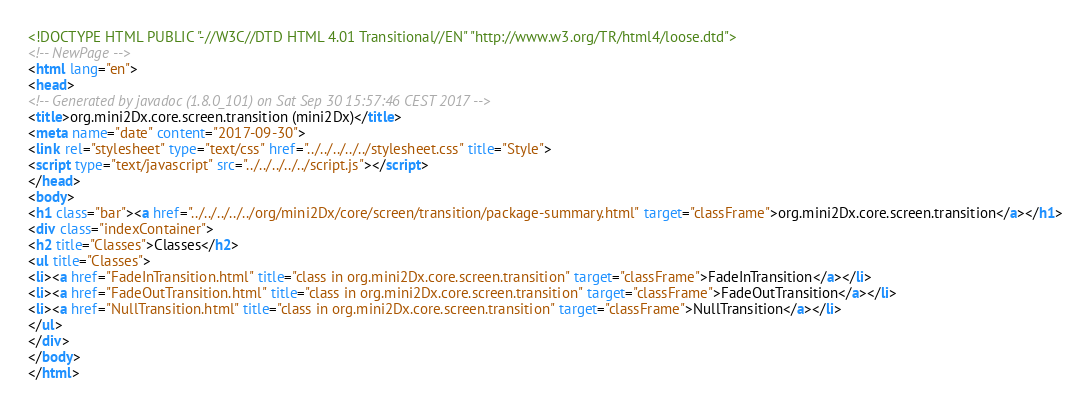Convert code to text. <code><loc_0><loc_0><loc_500><loc_500><_HTML_><!DOCTYPE HTML PUBLIC "-//W3C//DTD HTML 4.01 Transitional//EN" "http://www.w3.org/TR/html4/loose.dtd">
<!-- NewPage -->
<html lang="en">
<head>
<!-- Generated by javadoc (1.8.0_101) on Sat Sep 30 15:57:46 CEST 2017 -->
<title>org.mini2Dx.core.screen.transition (mini2Dx)</title>
<meta name="date" content="2017-09-30">
<link rel="stylesheet" type="text/css" href="../../../../../stylesheet.css" title="Style">
<script type="text/javascript" src="../../../../../script.js"></script>
</head>
<body>
<h1 class="bar"><a href="../../../../../org/mini2Dx/core/screen/transition/package-summary.html" target="classFrame">org.mini2Dx.core.screen.transition</a></h1>
<div class="indexContainer">
<h2 title="Classes">Classes</h2>
<ul title="Classes">
<li><a href="FadeInTransition.html" title="class in org.mini2Dx.core.screen.transition" target="classFrame">FadeInTransition</a></li>
<li><a href="FadeOutTransition.html" title="class in org.mini2Dx.core.screen.transition" target="classFrame">FadeOutTransition</a></li>
<li><a href="NullTransition.html" title="class in org.mini2Dx.core.screen.transition" target="classFrame">NullTransition</a></li>
</ul>
</div>
</body>
</html>
</code> 